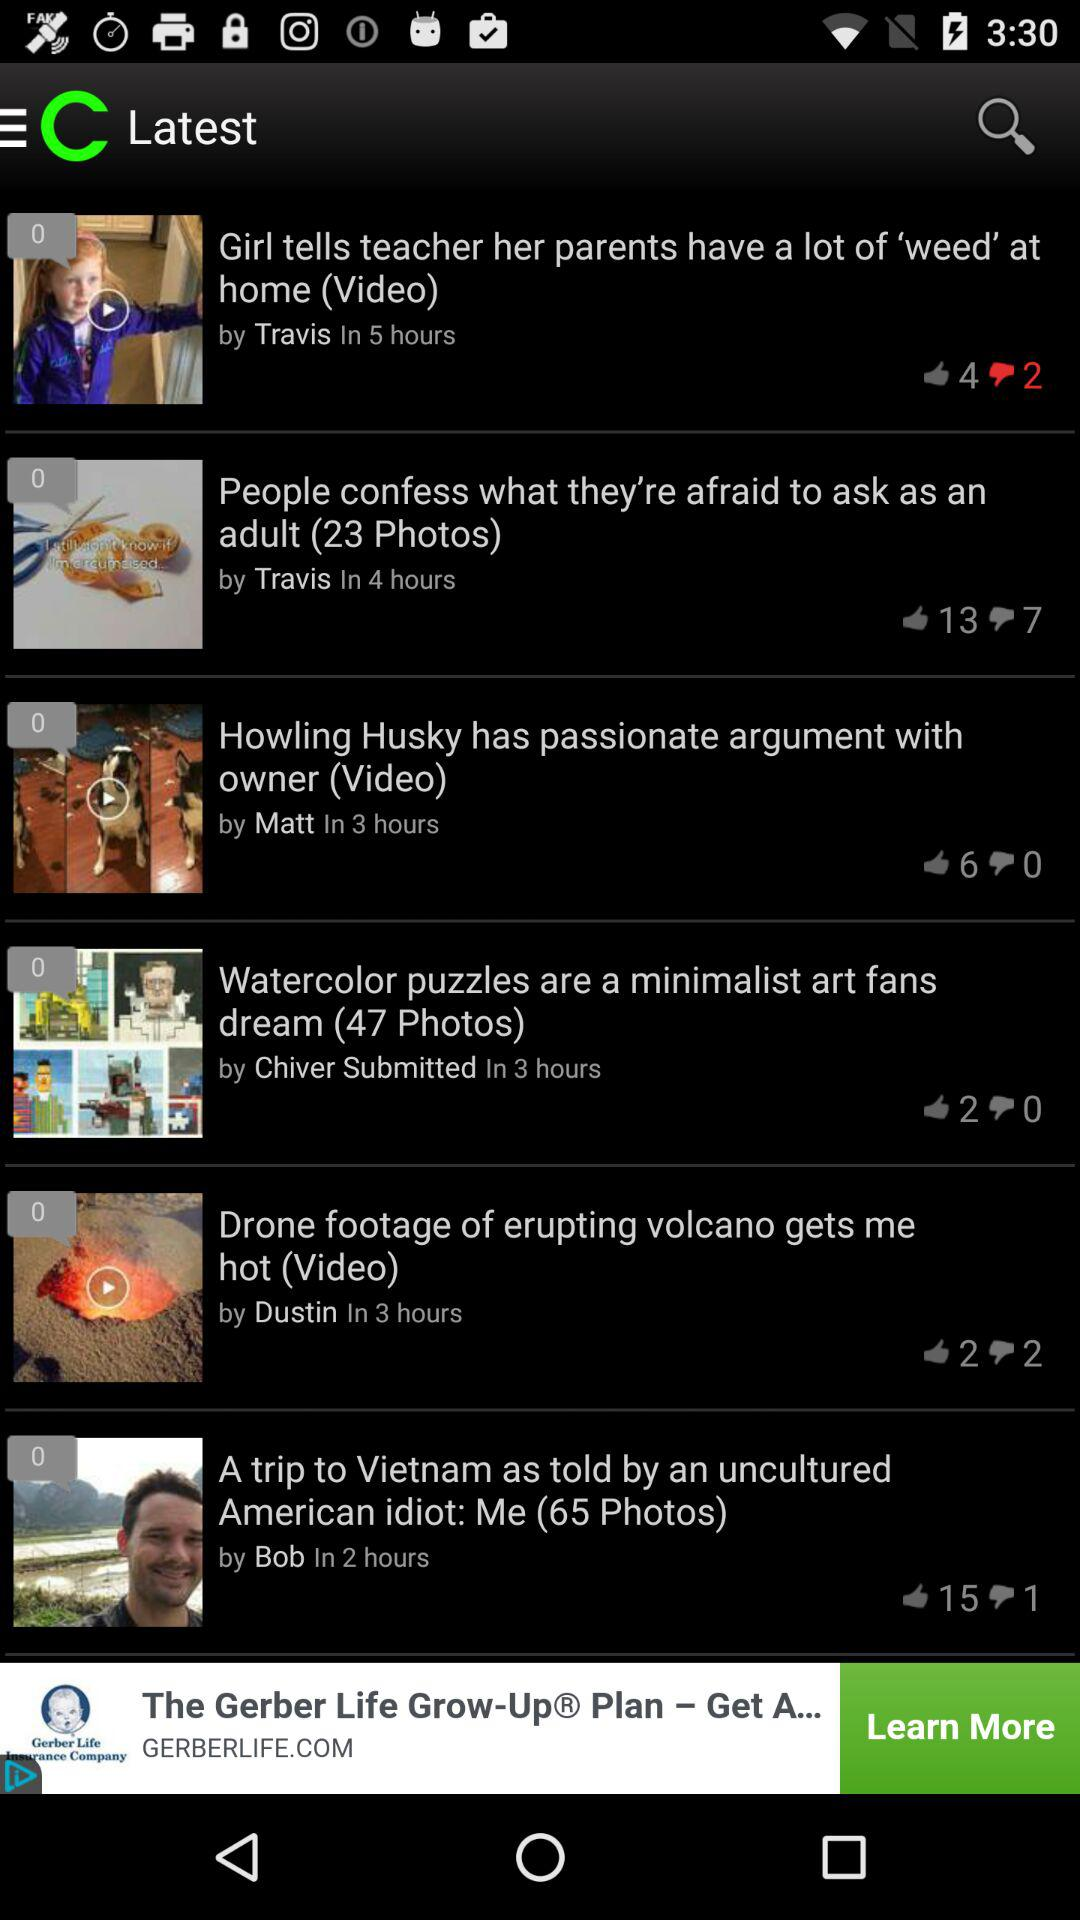Which post has one dislike? The post that has one dislike is "A trip to Vietnam as told by an uncultured American idiot: Me (65 Photos)". 